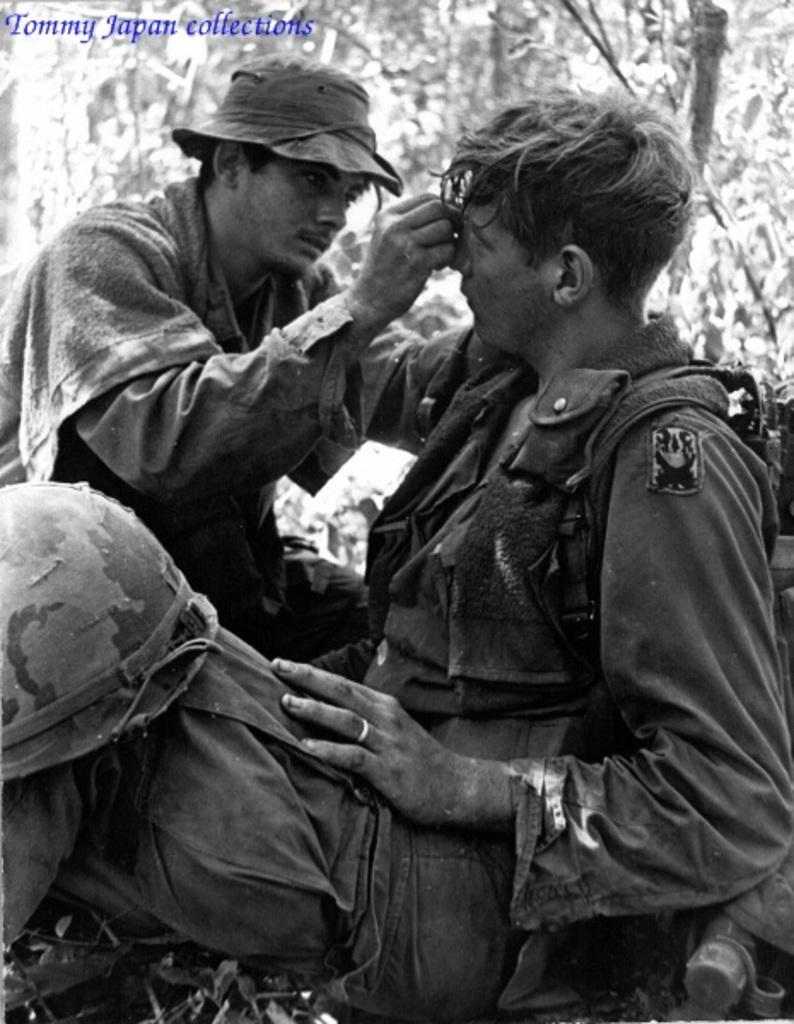How many people are in the image? There are persons in the image, but the exact number is not specified. What are the persons wearing? The persons are wearing clothes. What can be seen in the top left corner of the image? There is a text in the top left corner of the image. How would you describe the background of the image? The background of the image is blurred. What type of hose is being used by the persons in the image? There is no hose present in the image. Can you tell me how many drums are visible in the image? There is no drum present in the image. 